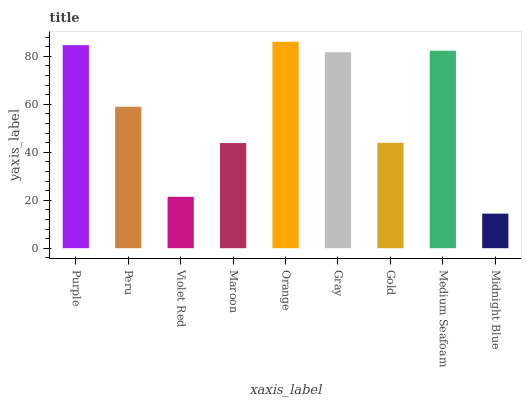Is Peru the minimum?
Answer yes or no. No. Is Peru the maximum?
Answer yes or no. No. Is Purple greater than Peru?
Answer yes or no. Yes. Is Peru less than Purple?
Answer yes or no. Yes. Is Peru greater than Purple?
Answer yes or no. No. Is Purple less than Peru?
Answer yes or no. No. Is Peru the high median?
Answer yes or no. Yes. Is Peru the low median?
Answer yes or no. Yes. Is Orange the high median?
Answer yes or no. No. Is Violet Red the low median?
Answer yes or no. No. 